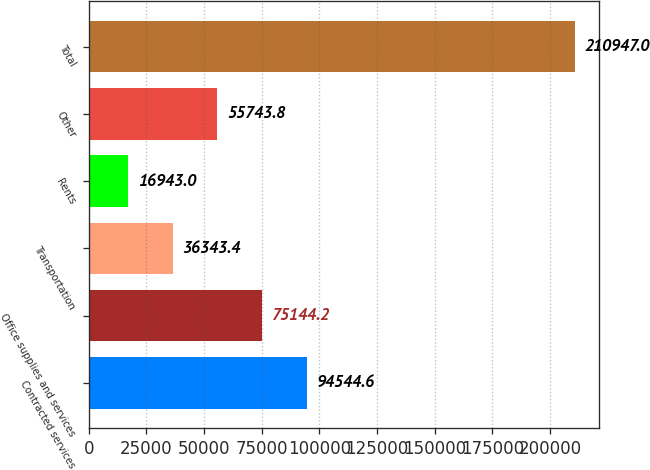Convert chart. <chart><loc_0><loc_0><loc_500><loc_500><bar_chart><fcel>Contracted services<fcel>Office supplies and services<fcel>Transportation<fcel>Rents<fcel>Other<fcel>Total<nl><fcel>94544.6<fcel>75144.2<fcel>36343.4<fcel>16943<fcel>55743.8<fcel>210947<nl></chart> 